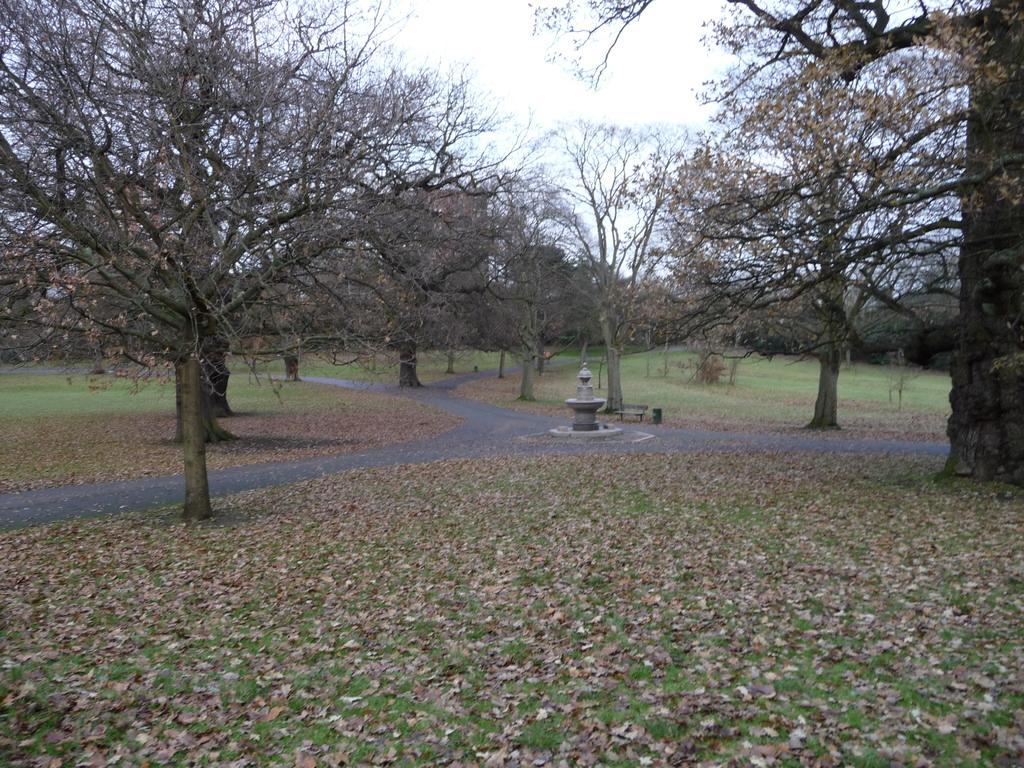Please provide a concise description of this image. In the picture I can see trees, the grass, roads, leaves on the ground and some other objects. In the background I can see the sky. 